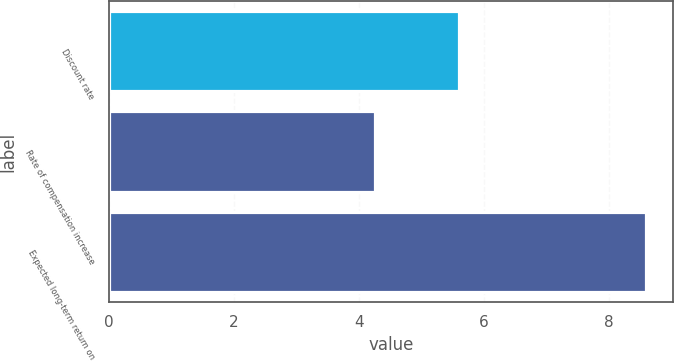Convert chart to OTSL. <chart><loc_0><loc_0><loc_500><loc_500><bar_chart><fcel>Discount rate<fcel>Rate of compensation increase<fcel>Expected long-term return on<nl><fcel>5.6<fcel>4.25<fcel>8.6<nl></chart> 